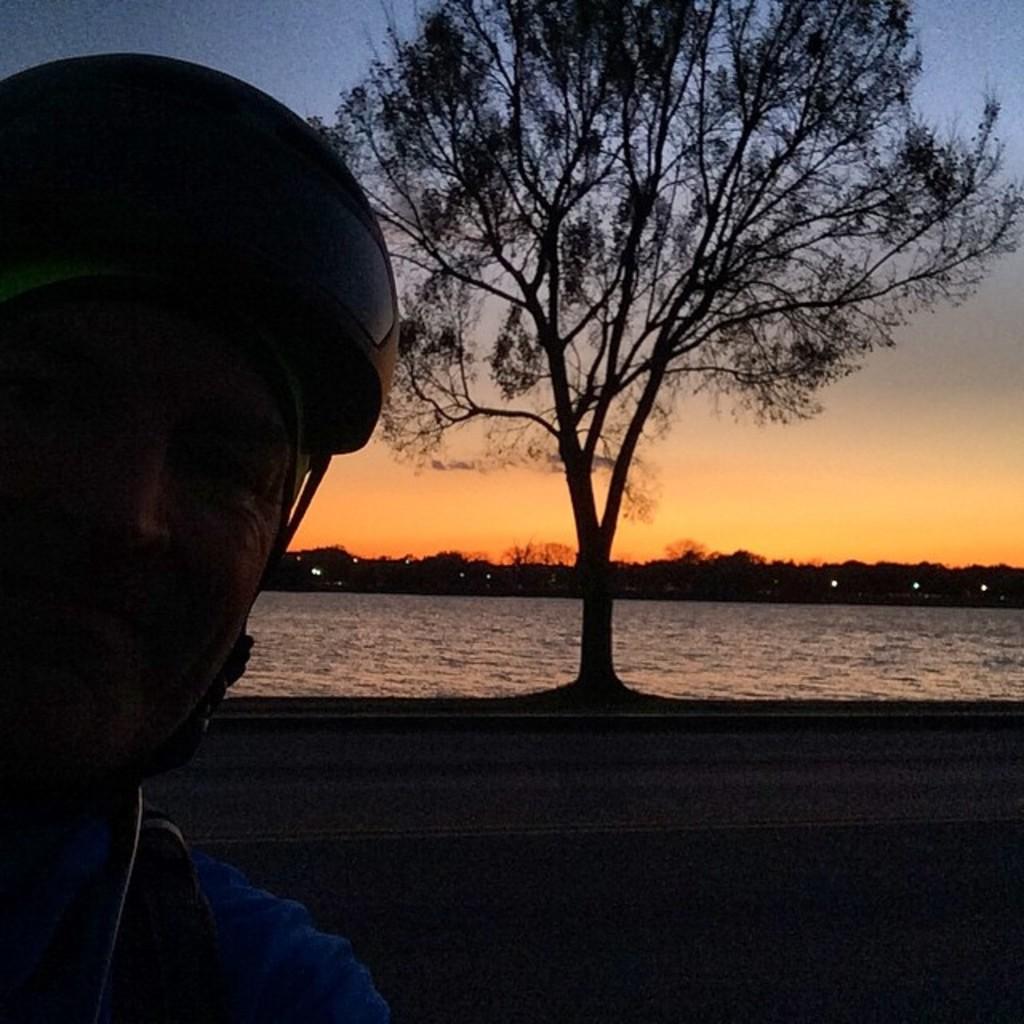Could you give a brief overview of what you see in this image? In the picture we can see a man wearing a helmet, near to him we can see a tree, water and some trees in the background and we can also see a sky with some sunshine. 